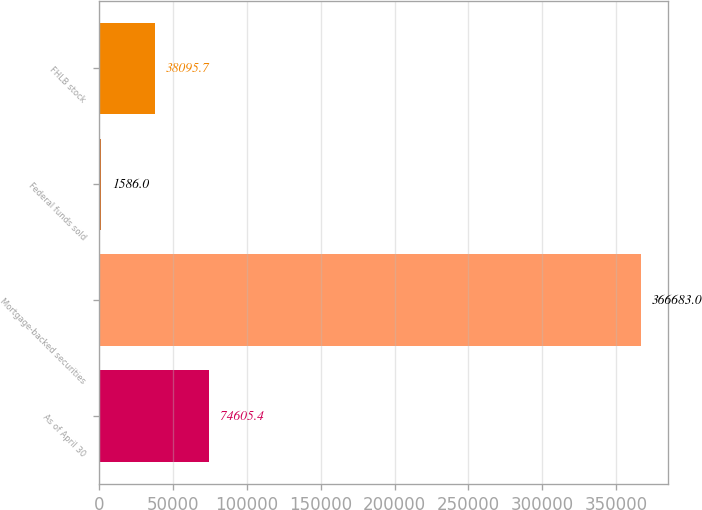Convert chart. <chart><loc_0><loc_0><loc_500><loc_500><bar_chart><fcel>As of April 30<fcel>Mortgage-backed securities<fcel>Federal funds sold<fcel>FHLB stock<nl><fcel>74605.4<fcel>366683<fcel>1586<fcel>38095.7<nl></chart> 